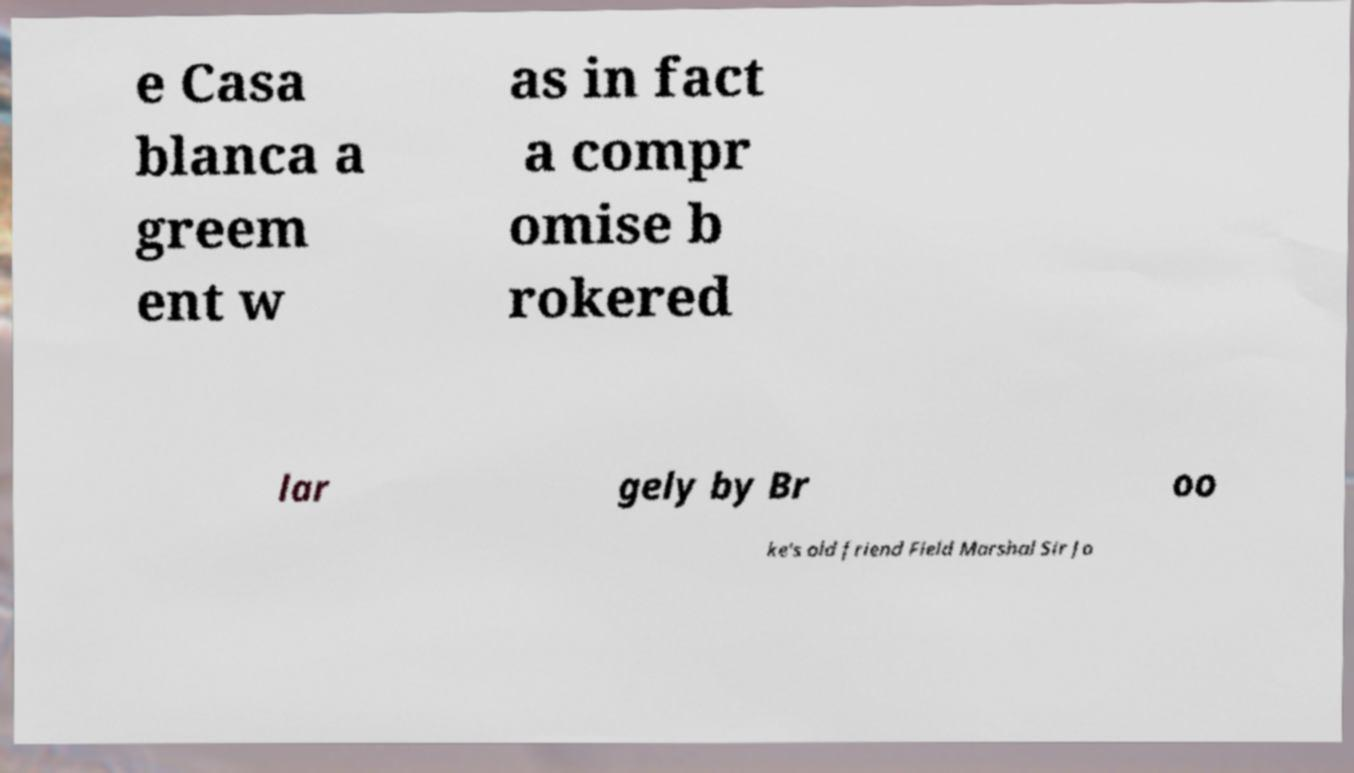What messages or text are displayed in this image? I need them in a readable, typed format. e Casa blanca a greem ent w as in fact a compr omise b rokered lar gely by Br oo ke's old friend Field Marshal Sir Jo 